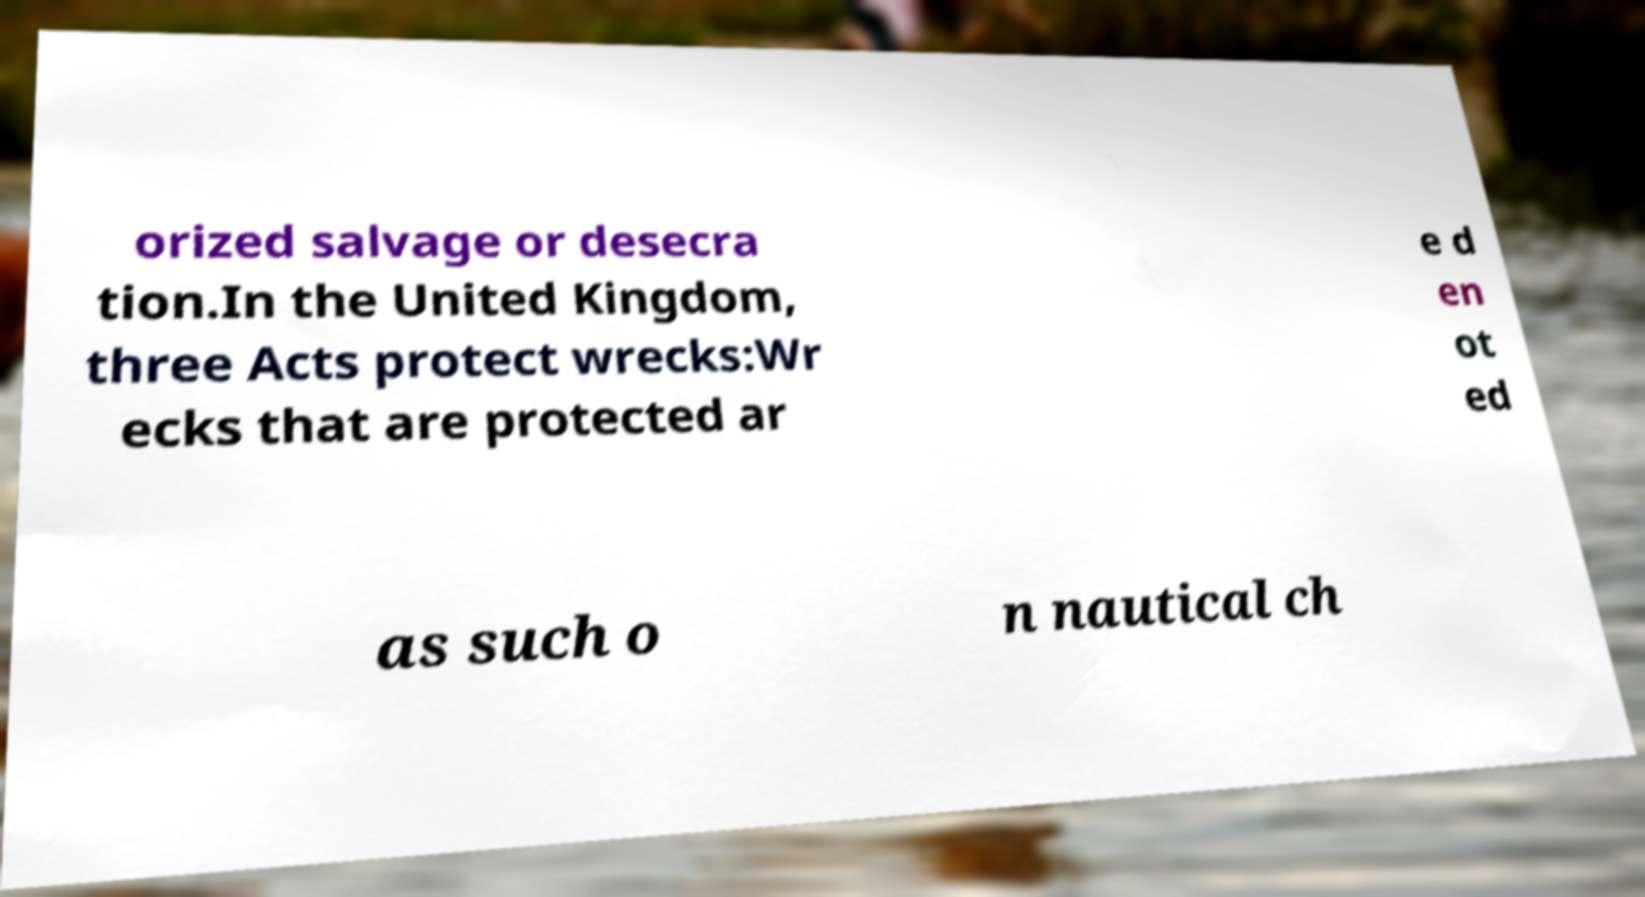Can you accurately transcribe the text from the provided image for me? orized salvage or desecra tion.In the United Kingdom, three Acts protect wrecks:Wr ecks that are protected ar e d en ot ed as such o n nautical ch 